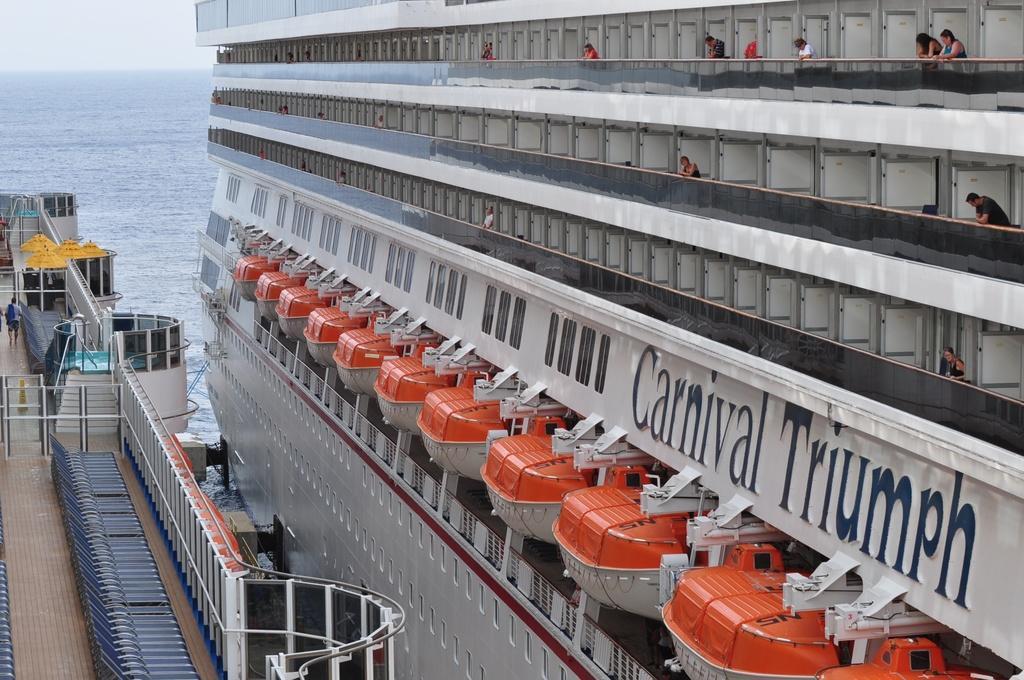Could you give a brief overview of what you see in this image? In this image we can see two ships. There are few people are standing in a various compartments of the ship. There is a sea in the image. 